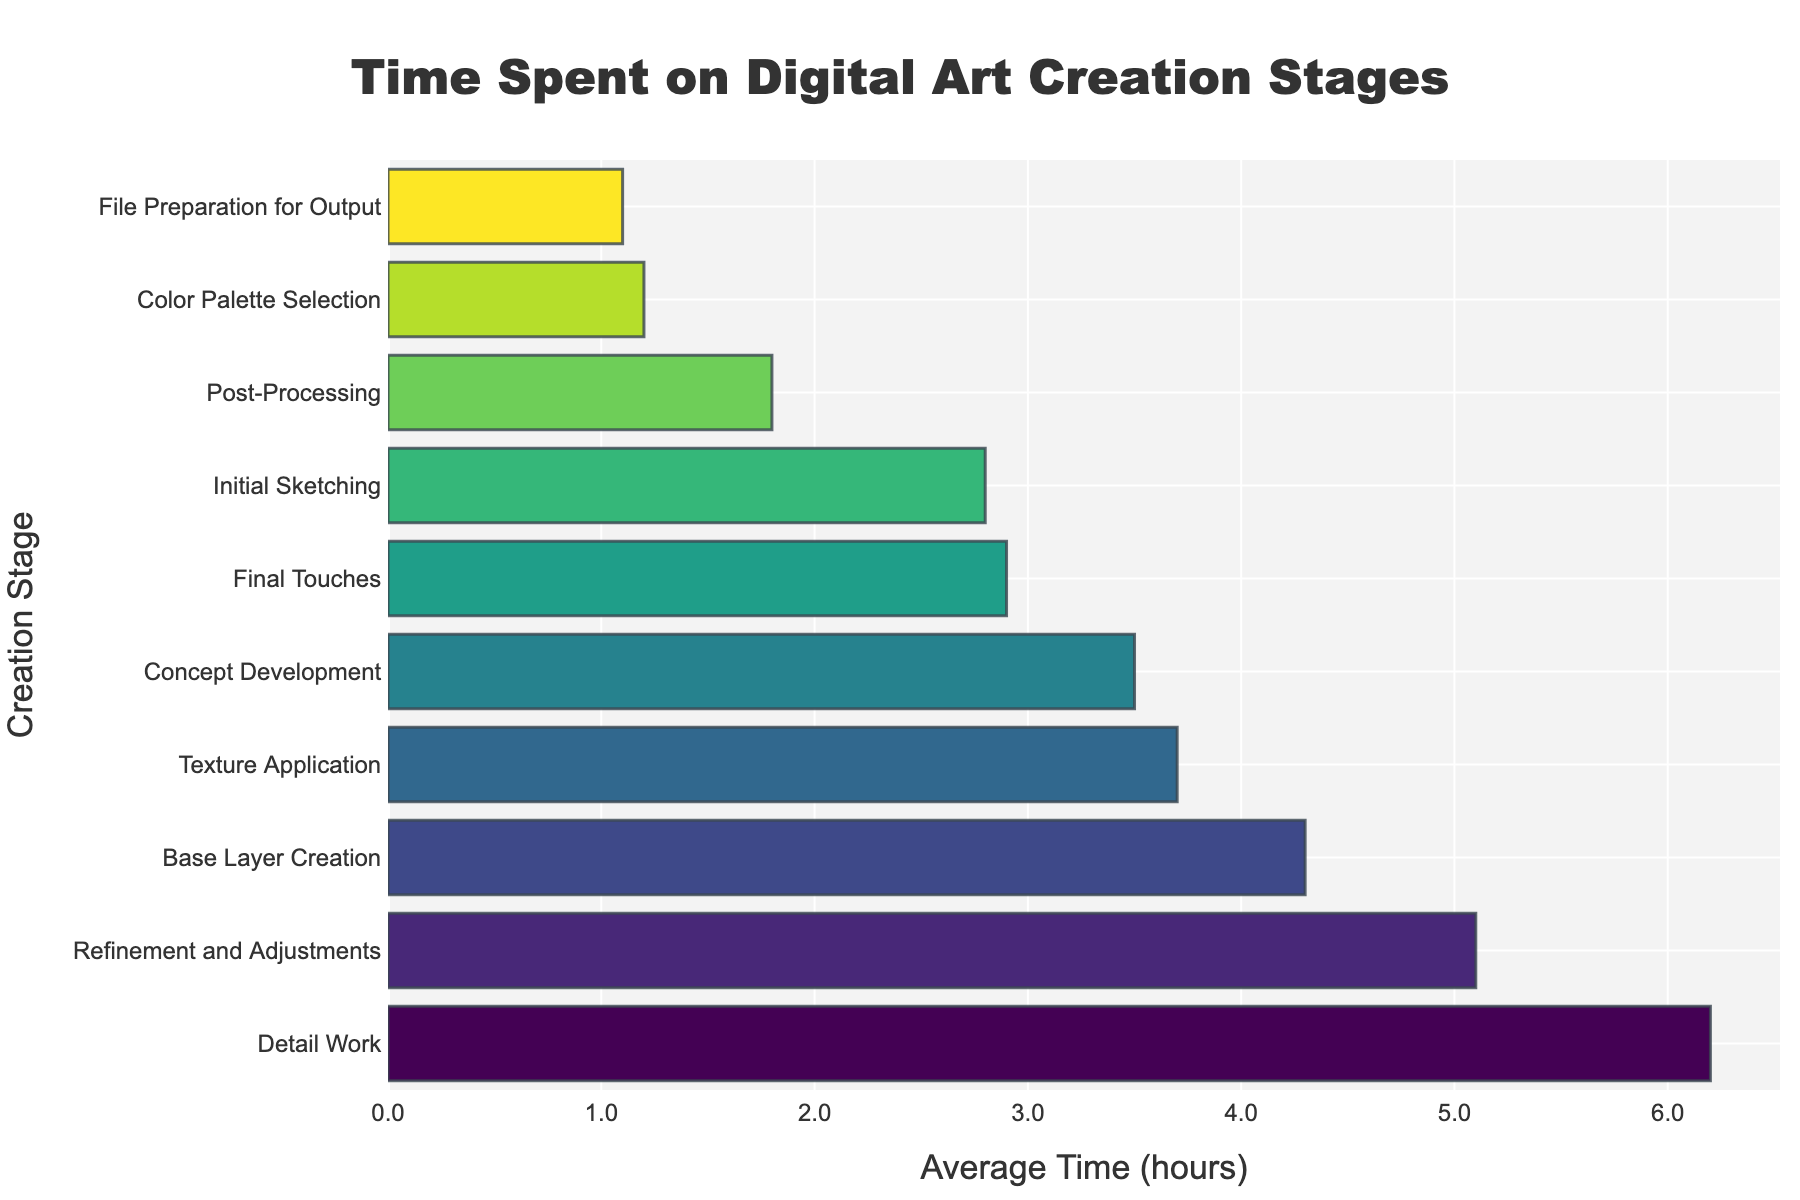Which creation stage takes the longest average time? By looking at the chart, the longest bar corresponds to the "Detail Work" stage, which takes 6.2 hours. This can be identified by comparing the lengths of the bars associated with each stage.
Answer: Detail Work Which stage takes less time: Initial Sketching or Refinement and Adjustments? By comparing the lengths of the bars for "Initial Sketching" and "Refinement and Adjustments," we see that "Initial Sketching" has a shorter bar corresponding to 2.8 hours, while "Refinement and Adjustments" has a longer bar corresponding to 5.1 hours. Hence, "Initial Sketching" takes less time.
Answer: Initial Sketching What is the total time spent on Concept Development and Base Layer Creation stages? The time spent on "Concept Development" is 3.5 hours and on "Base Layer Creation" is 4.3 hours. Adding these values together, 3.5 + 4.3 = 7.8 hours.
Answer: 7.8 hours How much more time is spent on Texture Application compared to Color Palette Selection? The average time for "Texture Application" is 3.7 hours, and for "Color Palette Selection" it is 1.2 hours. Subtracting these values, 3.7 - 1.2 = 2.5 hours.
Answer: 2.5 hours Which stages have an average time of 2 hours or less? By examining the chart, the stages with bars that represent 2 hours or less are "Color Palette Selection" (1.2 hours), "Post-Processing" (1.8 hours), and "File Preparation for Output" (1.1 hours).
Answer: Color Palette Selection, Post-Processing, File Preparation for Output What is the average time spent on the stages taking more than 4 hours? The stages with more than 4 hours are "Base Layer Creation" (4.3 hours), "Detail Work" (6.2 hours), and "Refinement and Adjustments" (5.1 hours). Adding these times, 4.3 + 6.2 + 5.1 = 15.6, and dividing by the number of stages (3), 15.6 / 3 = 5.2 hours.
Answer: 5.2 hours Which creation stages take more time compared to Final Touches? The average time for "Final Touches" is 2.9 hours. Stages that take more time than this are "Concept Development" (3.5 hours), "Base Layer Creation" (4.3 hours), "Texture Application" (3.7 hours), "Detail Work" (6.2 hours), and "Refinement and Adjustments" (5.1 hours).
Answer: Concept Development, Base Layer Creation, Texture Application, Detail Work, Refinement and Adjustments How much time is required on average for the last three stages? The last three stages are "Final Touches" (2.9 hours), "Post-Processing" (1.8 hours), and "File Preparation for Output" (1.1 hours). Summing these values, 2.9 + 1.8 + 1.1 = 5.8 hours.
Answer: 5.8 hours 